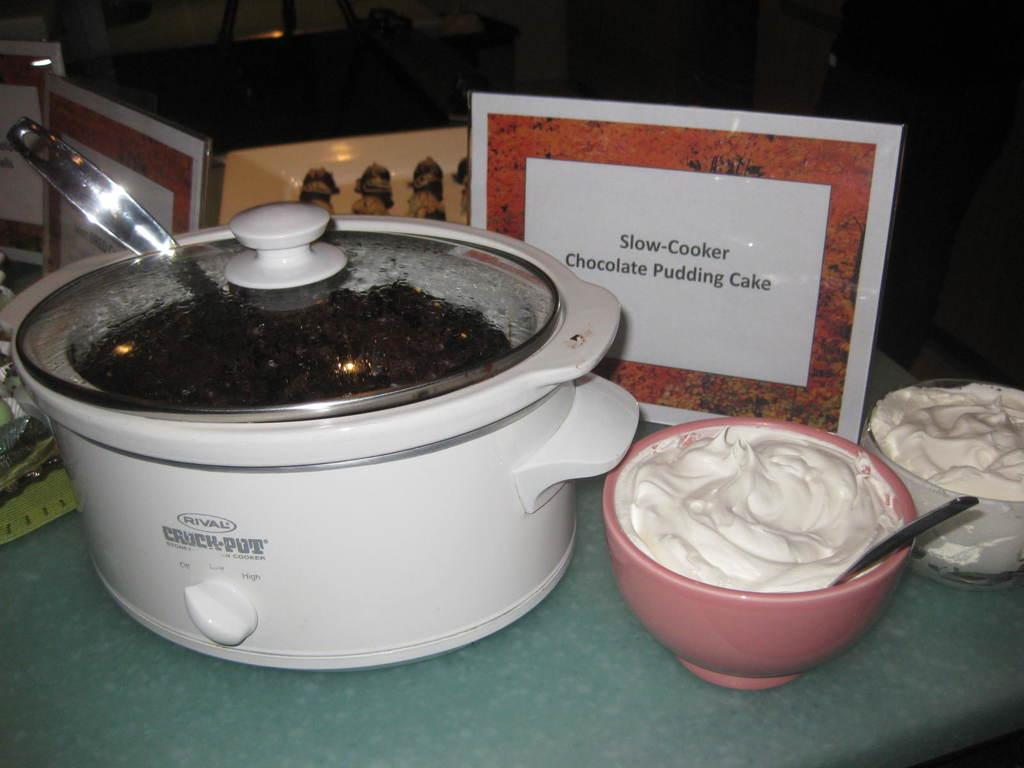<image>
Provide a brief description of the given image. A Rival Crock-Pot, next to containers of whip cream, contains Slow-Cooker Chocolate Pudding Cake. 